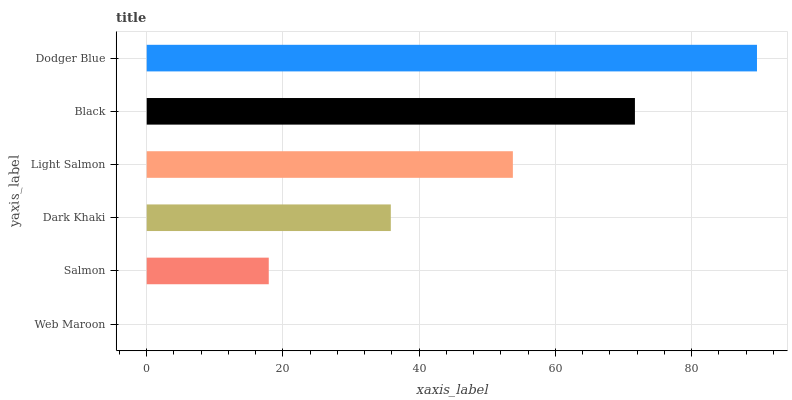Is Web Maroon the minimum?
Answer yes or no. Yes. Is Dodger Blue the maximum?
Answer yes or no. Yes. Is Salmon the minimum?
Answer yes or no. No. Is Salmon the maximum?
Answer yes or no. No. Is Salmon greater than Web Maroon?
Answer yes or no. Yes. Is Web Maroon less than Salmon?
Answer yes or no. Yes. Is Web Maroon greater than Salmon?
Answer yes or no. No. Is Salmon less than Web Maroon?
Answer yes or no. No. Is Light Salmon the high median?
Answer yes or no. Yes. Is Dark Khaki the low median?
Answer yes or no. Yes. Is Black the high median?
Answer yes or no. No. Is Web Maroon the low median?
Answer yes or no. No. 